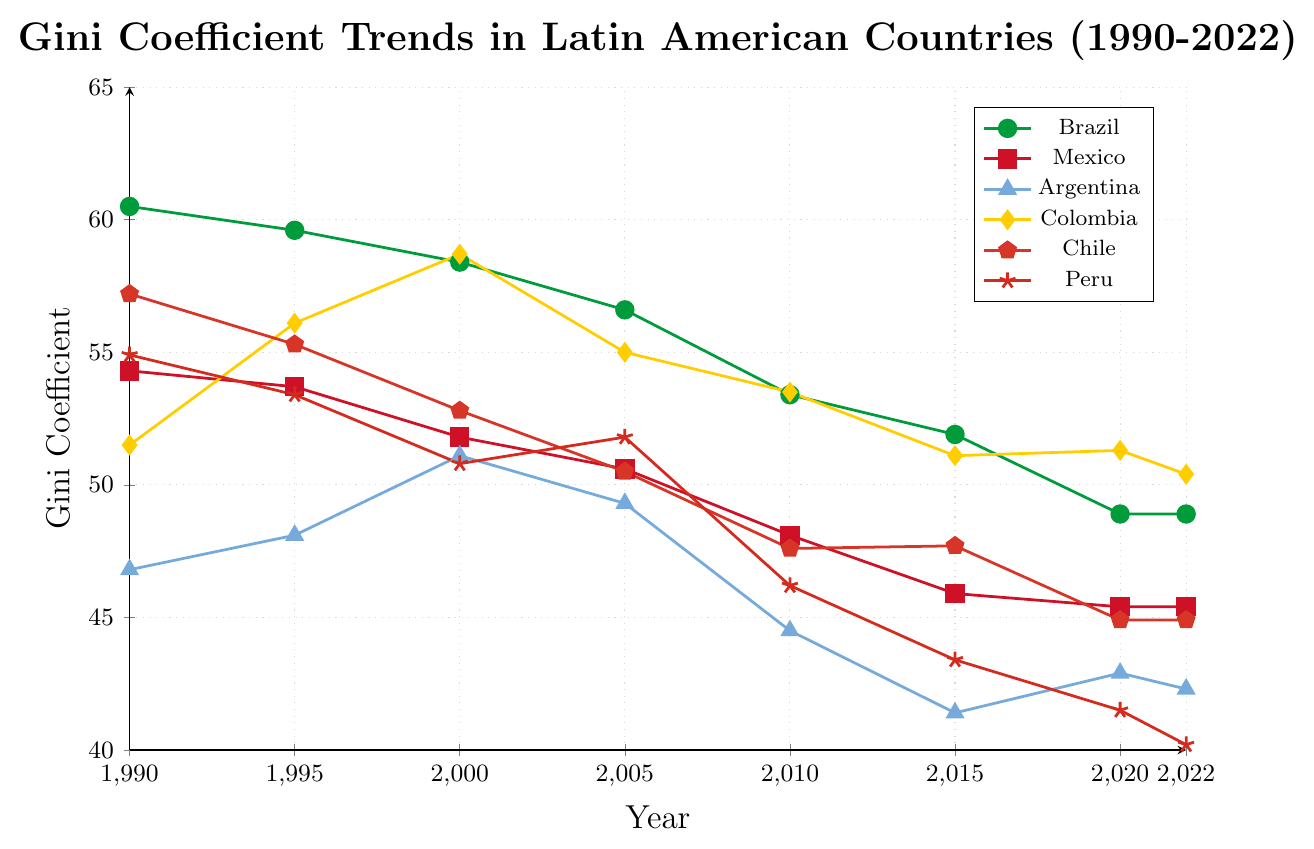**Question 1** **Explanation**
Answer: **Concise Answer** Which country had the highest Gini coefficient in 1990? To find the highest Gini coefficient in 1990, we look at the values for each country in that year. Brazil has the highest Gini coefficient at 60.5.
Answer: Brazil What is the difference in the Gini coefficient of Argentina from 1990 to 2022? The Gini coefficient for Argentina in 1990 is 46.8, and in 2022 it is 42.3. The difference is calculated as 46.8 - 42.3 = 4.5.
Answer: 4.5 Which country showed the most significant decrease in the Gini coefficient from 1990 to 2022? To determine this, we compute the difference for each country and compare: Brazil (60.5 - 48.9 = 11.6), Mexico (54.3 - 45.4 = 8.9), Argentina (46.8 - 42.3 = 4.5), Colombia (51.5 - 50.4 = 1.1), Chile (57.2 - 44.9 = 12.3), Peru (54.9 - 40.2 = 14.7). The most significant decrease is for Peru at 14.7.
Answer: Peru In which year did Brazil and Mexico have the smallest difference in their Gini coefficients? Calculating the difference for each year: 1990 (6.2), 1995 (5.9), 2000 (6.6), 2005 (6.0), 2010 (5.3), 2015 (6.0), 2020 (3.5), 2022 (3.5). The smallest differences are in 2020 and 2022, both with 3.5.
Answer: 2020 and 2022 What is the average Gini coefficient of Chile over the period 1990-2022? First, we sum the Gini coefficients for Chile: 57.2 + 55.3 + 52.8 + 50.5 + 47.6 + 47.7 + 44.9 + 44.9 = 401.9. Then, we divide by the number of years (8): 401.9 / 8 = 50.2375.
Answer: 50.2375 Between Peru and Colombia, which country had a lower Gini coefficient in 2010? In 2010, the Gini coefficient for Peru was 46.2 and for Colombia, it was 53.5. Therefore, Peru had a lower Gini coefficient.
Answer: Peru What is the trend pattern for the Gini coefficient in Peru from 1990 to 2022? The trend for Peru shows a steady decrease over the years: 54.9 (1990), 53.4 (1995), 50.8 (2000), 51.8 (2005), 46.2 (2010), 43.4 (2015), 41.5 (2020), 40.2 (2022). It illustrates a consistent decline.
Answer: Consistent decline Which year had the highest Gini coefficient for Colombia? Observing Colombia's values: 1990 (51.5), 1995 (56.1), 2000 (58.7), 2005 (55.0), 2010 (53.5), 2015 (51.1), 2020 (51.3), 2022 (50.4), the highest Gini coefficient is in 2000 at 58.7.
Answer: 2000 How many countries had a Gini coefficient below 50 in 2022? In 2022, the countries with a Gini coefficient below 50 are Brazil (48.9), Mexico (45.4), Argentina (42.3), Chile (44.9), Peru (40.2). This sums up to 5 countries.
Answer: 5 